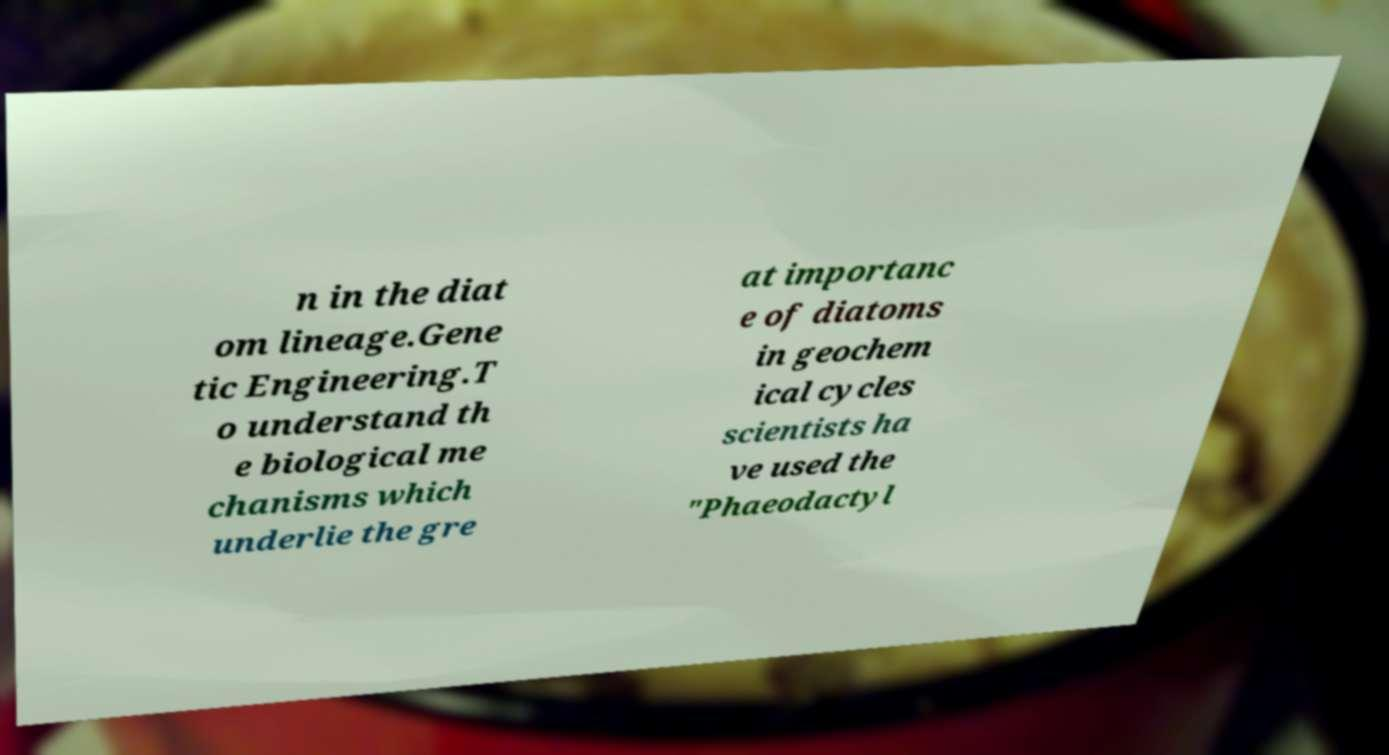Could you extract and type out the text from this image? n in the diat om lineage.Gene tic Engineering.T o understand th e biological me chanisms which underlie the gre at importanc e of diatoms in geochem ical cycles scientists ha ve used the "Phaeodactyl 